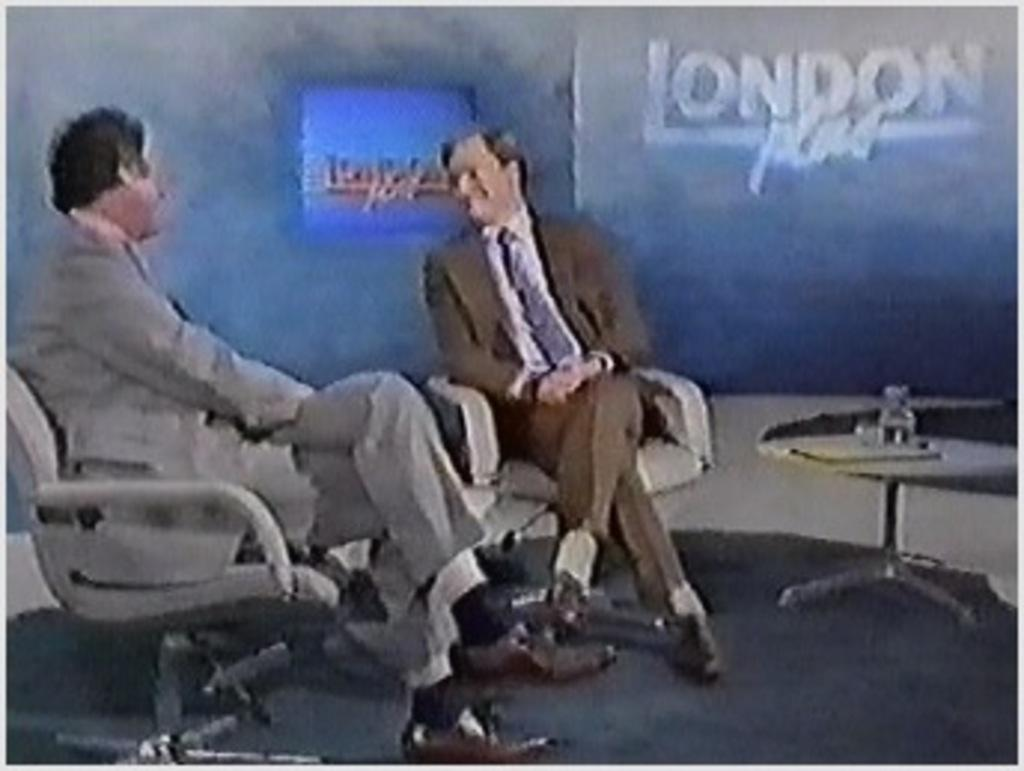How many people are in the image? There are two men in the image. What are the men doing in the image? The men are sitting on chairs. What is located in front of the men? There is a table in front of the men. What can be seen in the background of the image? There is a wall in the background of the image. What type of skirt is the boat wearing in the image? There is no boat or skirt present in the image. Is there a birthday celebration happening in the image? There is no indication of a birthday celebration in the image. 